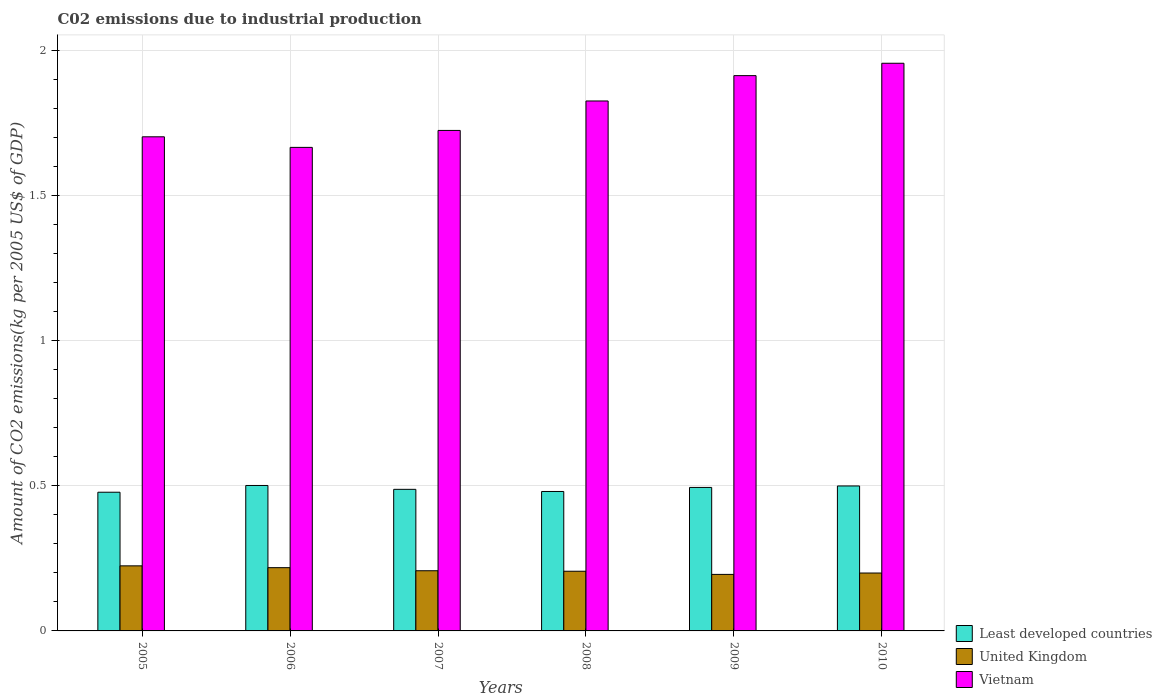How many different coloured bars are there?
Provide a succinct answer. 3. Are the number of bars per tick equal to the number of legend labels?
Your response must be concise. Yes. How many bars are there on the 3rd tick from the right?
Offer a terse response. 3. What is the label of the 5th group of bars from the left?
Ensure brevity in your answer.  2009. What is the amount of CO2 emitted due to industrial production in Least developed countries in 2006?
Provide a short and direct response. 0.5. Across all years, what is the maximum amount of CO2 emitted due to industrial production in United Kingdom?
Offer a terse response. 0.22. Across all years, what is the minimum amount of CO2 emitted due to industrial production in United Kingdom?
Offer a very short reply. 0.19. In which year was the amount of CO2 emitted due to industrial production in United Kingdom minimum?
Offer a terse response. 2009. What is the total amount of CO2 emitted due to industrial production in Least developed countries in the graph?
Give a very brief answer. 2.94. What is the difference between the amount of CO2 emitted due to industrial production in Vietnam in 2007 and that in 2008?
Keep it short and to the point. -0.1. What is the difference between the amount of CO2 emitted due to industrial production in Vietnam in 2010 and the amount of CO2 emitted due to industrial production in Least developed countries in 2005?
Offer a terse response. 1.48. What is the average amount of CO2 emitted due to industrial production in United Kingdom per year?
Provide a succinct answer. 0.21. In the year 2006, what is the difference between the amount of CO2 emitted due to industrial production in United Kingdom and amount of CO2 emitted due to industrial production in Least developed countries?
Provide a short and direct response. -0.28. What is the ratio of the amount of CO2 emitted due to industrial production in Least developed countries in 2006 to that in 2007?
Give a very brief answer. 1.03. Is the amount of CO2 emitted due to industrial production in Vietnam in 2007 less than that in 2008?
Offer a terse response. Yes. Is the difference between the amount of CO2 emitted due to industrial production in United Kingdom in 2005 and 2006 greater than the difference between the amount of CO2 emitted due to industrial production in Least developed countries in 2005 and 2006?
Provide a succinct answer. Yes. What is the difference between the highest and the second highest amount of CO2 emitted due to industrial production in United Kingdom?
Your answer should be compact. 0.01. What is the difference between the highest and the lowest amount of CO2 emitted due to industrial production in Least developed countries?
Provide a succinct answer. 0.02. Is the sum of the amount of CO2 emitted due to industrial production in Vietnam in 2009 and 2010 greater than the maximum amount of CO2 emitted due to industrial production in United Kingdom across all years?
Give a very brief answer. Yes. What does the 3rd bar from the left in 2008 represents?
Make the answer very short. Vietnam. What does the 2nd bar from the right in 2005 represents?
Keep it short and to the point. United Kingdom. How many bars are there?
Provide a short and direct response. 18. How many years are there in the graph?
Offer a terse response. 6. Does the graph contain any zero values?
Give a very brief answer. No. Does the graph contain grids?
Provide a short and direct response. Yes. Where does the legend appear in the graph?
Offer a very short reply. Bottom right. What is the title of the graph?
Provide a short and direct response. C02 emissions due to industrial production. What is the label or title of the Y-axis?
Give a very brief answer. Amount of CO2 emissions(kg per 2005 US$ of GDP). What is the Amount of CO2 emissions(kg per 2005 US$ of GDP) in Least developed countries in 2005?
Your response must be concise. 0.48. What is the Amount of CO2 emissions(kg per 2005 US$ of GDP) of United Kingdom in 2005?
Offer a very short reply. 0.22. What is the Amount of CO2 emissions(kg per 2005 US$ of GDP) of Vietnam in 2005?
Provide a succinct answer. 1.7. What is the Amount of CO2 emissions(kg per 2005 US$ of GDP) in Least developed countries in 2006?
Provide a short and direct response. 0.5. What is the Amount of CO2 emissions(kg per 2005 US$ of GDP) in United Kingdom in 2006?
Offer a very short reply. 0.22. What is the Amount of CO2 emissions(kg per 2005 US$ of GDP) in Vietnam in 2006?
Your answer should be very brief. 1.67. What is the Amount of CO2 emissions(kg per 2005 US$ of GDP) of Least developed countries in 2007?
Your answer should be very brief. 0.49. What is the Amount of CO2 emissions(kg per 2005 US$ of GDP) of United Kingdom in 2007?
Offer a terse response. 0.21. What is the Amount of CO2 emissions(kg per 2005 US$ of GDP) in Vietnam in 2007?
Offer a terse response. 1.72. What is the Amount of CO2 emissions(kg per 2005 US$ of GDP) of Least developed countries in 2008?
Ensure brevity in your answer.  0.48. What is the Amount of CO2 emissions(kg per 2005 US$ of GDP) in United Kingdom in 2008?
Make the answer very short. 0.21. What is the Amount of CO2 emissions(kg per 2005 US$ of GDP) of Vietnam in 2008?
Your answer should be compact. 1.83. What is the Amount of CO2 emissions(kg per 2005 US$ of GDP) of Least developed countries in 2009?
Your response must be concise. 0.49. What is the Amount of CO2 emissions(kg per 2005 US$ of GDP) of United Kingdom in 2009?
Offer a very short reply. 0.19. What is the Amount of CO2 emissions(kg per 2005 US$ of GDP) of Vietnam in 2009?
Provide a succinct answer. 1.91. What is the Amount of CO2 emissions(kg per 2005 US$ of GDP) in Least developed countries in 2010?
Your answer should be very brief. 0.5. What is the Amount of CO2 emissions(kg per 2005 US$ of GDP) in United Kingdom in 2010?
Make the answer very short. 0.2. What is the Amount of CO2 emissions(kg per 2005 US$ of GDP) in Vietnam in 2010?
Make the answer very short. 1.96. Across all years, what is the maximum Amount of CO2 emissions(kg per 2005 US$ of GDP) of Least developed countries?
Ensure brevity in your answer.  0.5. Across all years, what is the maximum Amount of CO2 emissions(kg per 2005 US$ of GDP) in United Kingdom?
Provide a succinct answer. 0.22. Across all years, what is the maximum Amount of CO2 emissions(kg per 2005 US$ of GDP) of Vietnam?
Offer a terse response. 1.96. Across all years, what is the minimum Amount of CO2 emissions(kg per 2005 US$ of GDP) in Least developed countries?
Provide a short and direct response. 0.48. Across all years, what is the minimum Amount of CO2 emissions(kg per 2005 US$ of GDP) in United Kingdom?
Your response must be concise. 0.19. Across all years, what is the minimum Amount of CO2 emissions(kg per 2005 US$ of GDP) in Vietnam?
Your response must be concise. 1.67. What is the total Amount of CO2 emissions(kg per 2005 US$ of GDP) of Least developed countries in the graph?
Ensure brevity in your answer.  2.94. What is the total Amount of CO2 emissions(kg per 2005 US$ of GDP) of United Kingdom in the graph?
Offer a terse response. 1.25. What is the total Amount of CO2 emissions(kg per 2005 US$ of GDP) of Vietnam in the graph?
Keep it short and to the point. 10.79. What is the difference between the Amount of CO2 emissions(kg per 2005 US$ of GDP) of Least developed countries in 2005 and that in 2006?
Keep it short and to the point. -0.02. What is the difference between the Amount of CO2 emissions(kg per 2005 US$ of GDP) in United Kingdom in 2005 and that in 2006?
Keep it short and to the point. 0.01. What is the difference between the Amount of CO2 emissions(kg per 2005 US$ of GDP) in Vietnam in 2005 and that in 2006?
Offer a terse response. 0.04. What is the difference between the Amount of CO2 emissions(kg per 2005 US$ of GDP) in Least developed countries in 2005 and that in 2007?
Keep it short and to the point. -0.01. What is the difference between the Amount of CO2 emissions(kg per 2005 US$ of GDP) of United Kingdom in 2005 and that in 2007?
Provide a succinct answer. 0.02. What is the difference between the Amount of CO2 emissions(kg per 2005 US$ of GDP) in Vietnam in 2005 and that in 2007?
Your answer should be compact. -0.02. What is the difference between the Amount of CO2 emissions(kg per 2005 US$ of GDP) of Least developed countries in 2005 and that in 2008?
Keep it short and to the point. -0. What is the difference between the Amount of CO2 emissions(kg per 2005 US$ of GDP) of United Kingdom in 2005 and that in 2008?
Make the answer very short. 0.02. What is the difference between the Amount of CO2 emissions(kg per 2005 US$ of GDP) in Vietnam in 2005 and that in 2008?
Your response must be concise. -0.12. What is the difference between the Amount of CO2 emissions(kg per 2005 US$ of GDP) in Least developed countries in 2005 and that in 2009?
Give a very brief answer. -0.02. What is the difference between the Amount of CO2 emissions(kg per 2005 US$ of GDP) of United Kingdom in 2005 and that in 2009?
Your answer should be compact. 0.03. What is the difference between the Amount of CO2 emissions(kg per 2005 US$ of GDP) of Vietnam in 2005 and that in 2009?
Your response must be concise. -0.21. What is the difference between the Amount of CO2 emissions(kg per 2005 US$ of GDP) in Least developed countries in 2005 and that in 2010?
Provide a succinct answer. -0.02. What is the difference between the Amount of CO2 emissions(kg per 2005 US$ of GDP) of United Kingdom in 2005 and that in 2010?
Give a very brief answer. 0.02. What is the difference between the Amount of CO2 emissions(kg per 2005 US$ of GDP) in Vietnam in 2005 and that in 2010?
Provide a succinct answer. -0.25. What is the difference between the Amount of CO2 emissions(kg per 2005 US$ of GDP) of Least developed countries in 2006 and that in 2007?
Keep it short and to the point. 0.01. What is the difference between the Amount of CO2 emissions(kg per 2005 US$ of GDP) in United Kingdom in 2006 and that in 2007?
Offer a very short reply. 0.01. What is the difference between the Amount of CO2 emissions(kg per 2005 US$ of GDP) in Vietnam in 2006 and that in 2007?
Your answer should be very brief. -0.06. What is the difference between the Amount of CO2 emissions(kg per 2005 US$ of GDP) of Least developed countries in 2006 and that in 2008?
Give a very brief answer. 0.02. What is the difference between the Amount of CO2 emissions(kg per 2005 US$ of GDP) in United Kingdom in 2006 and that in 2008?
Offer a terse response. 0.01. What is the difference between the Amount of CO2 emissions(kg per 2005 US$ of GDP) of Vietnam in 2006 and that in 2008?
Ensure brevity in your answer.  -0.16. What is the difference between the Amount of CO2 emissions(kg per 2005 US$ of GDP) of Least developed countries in 2006 and that in 2009?
Provide a succinct answer. 0.01. What is the difference between the Amount of CO2 emissions(kg per 2005 US$ of GDP) in United Kingdom in 2006 and that in 2009?
Your answer should be very brief. 0.02. What is the difference between the Amount of CO2 emissions(kg per 2005 US$ of GDP) of Vietnam in 2006 and that in 2009?
Your answer should be very brief. -0.25. What is the difference between the Amount of CO2 emissions(kg per 2005 US$ of GDP) in Least developed countries in 2006 and that in 2010?
Your response must be concise. 0. What is the difference between the Amount of CO2 emissions(kg per 2005 US$ of GDP) of United Kingdom in 2006 and that in 2010?
Make the answer very short. 0.02. What is the difference between the Amount of CO2 emissions(kg per 2005 US$ of GDP) in Vietnam in 2006 and that in 2010?
Keep it short and to the point. -0.29. What is the difference between the Amount of CO2 emissions(kg per 2005 US$ of GDP) in Least developed countries in 2007 and that in 2008?
Give a very brief answer. 0.01. What is the difference between the Amount of CO2 emissions(kg per 2005 US$ of GDP) of United Kingdom in 2007 and that in 2008?
Provide a succinct answer. 0. What is the difference between the Amount of CO2 emissions(kg per 2005 US$ of GDP) in Vietnam in 2007 and that in 2008?
Offer a terse response. -0.1. What is the difference between the Amount of CO2 emissions(kg per 2005 US$ of GDP) of Least developed countries in 2007 and that in 2009?
Give a very brief answer. -0.01. What is the difference between the Amount of CO2 emissions(kg per 2005 US$ of GDP) of United Kingdom in 2007 and that in 2009?
Make the answer very short. 0.01. What is the difference between the Amount of CO2 emissions(kg per 2005 US$ of GDP) of Vietnam in 2007 and that in 2009?
Your response must be concise. -0.19. What is the difference between the Amount of CO2 emissions(kg per 2005 US$ of GDP) in Least developed countries in 2007 and that in 2010?
Your answer should be very brief. -0.01. What is the difference between the Amount of CO2 emissions(kg per 2005 US$ of GDP) in United Kingdom in 2007 and that in 2010?
Make the answer very short. 0.01. What is the difference between the Amount of CO2 emissions(kg per 2005 US$ of GDP) in Vietnam in 2007 and that in 2010?
Offer a very short reply. -0.23. What is the difference between the Amount of CO2 emissions(kg per 2005 US$ of GDP) in Least developed countries in 2008 and that in 2009?
Your response must be concise. -0.01. What is the difference between the Amount of CO2 emissions(kg per 2005 US$ of GDP) in United Kingdom in 2008 and that in 2009?
Give a very brief answer. 0.01. What is the difference between the Amount of CO2 emissions(kg per 2005 US$ of GDP) in Vietnam in 2008 and that in 2009?
Your answer should be compact. -0.09. What is the difference between the Amount of CO2 emissions(kg per 2005 US$ of GDP) in Least developed countries in 2008 and that in 2010?
Provide a succinct answer. -0.02. What is the difference between the Amount of CO2 emissions(kg per 2005 US$ of GDP) in United Kingdom in 2008 and that in 2010?
Make the answer very short. 0.01. What is the difference between the Amount of CO2 emissions(kg per 2005 US$ of GDP) of Vietnam in 2008 and that in 2010?
Offer a very short reply. -0.13. What is the difference between the Amount of CO2 emissions(kg per 2005 US$ of GDP) of Least developed countries in 2009 and that in 2010?
Provide a succinct answer. -0.01. What is the difference between the Amount of CO2 emissions(kg per 2005 US$ of GDP) in United Kingdom in 2009 and that in 2010?
Offer a terse response. -0. What is the difference between the Amount of CO2 emissions(kg per 2005 US$ of GDP) of Vietnam in 2009 and that in 2010?
Provide a succinct answer. -0.04. What is the difference between the Amount of CO2 emissions(kg per 2005 US$ of GDP) in Least developed countries in 2005 and the Amount of CO2 emissions(kg per 2005 US$ of GDP) in United Kingdom in 2006?
Provide a short and direct response. 0.26. What is the difference between the Amount of CO2 emissions(kg per 2005 US$ of GDP) in Least developed countries in 2005 and the Amount of CO2 emissions(kg per 2005 US$ of GDP) in Vietnam in 2006?
Provide a succinct answer. -1.19. What is the difference between the Amount of CO2 emissions(kg per 2005 US$ of GDP) in United Kingdom in 2005 and the Amount of CO2 emissions(kg per 2005 US$ of GDP) in Vietnam in 2006?
Ensure brevity in your answer.  -1.44. What is the difference between the Amount of CO2 emissions(kg per 2005 US$ of GDP) of Least developed countries in 2005 and the Amount of CO2 emissions(kg per 2005 US$ of GDP) of United Kingdom in 2007?
Keep it short and to the point. 0.27. What is the difference between the Amount of CO2 emissions(kg per 2005 US$ of GDP) of Least developed countries in 2005 and the Amount of CO2 emissions(kg per 2005 US$ of GDP) of Vietnam in 2007?
Provide a short and direct response. -1.25. What is the difference between the Amount of CO2 emissions(kg per 2005 US$ of GDP) in United Kingdom in 2005 and the Amount of CO2 emissions(kg per 2005 US$ of GDP) in Vietnam in 2007?
Ensure brevity in your answer.  -1.5. What is the difference between the Amount of CO2 emissions(kg per 2005 US$ of GDP) of Least developed countries in 2005 and the Amount of CO2 emissions(kg per 2005 US$ of GDP) of United Kingdom in 2008?
Provide a succinct answer. 0.27. What is the difference between the Amount of CO2 emissions(kg per 2005 US$ of GDP) of Least developed countries in 2005 and the Amount of CO2 emissions(kg per 2005 US$ of GDP) of Vietnam in 2008?
Provide a short and direct response. -1.35. What is the difference between the Amount of CO2 emissions(kg per 2005 US$ of GDP) of United Kingdom in 2005 and the Amount of CO2 emissions(kg per 2005 US$ of GDP) of Vietnam in 2008?
Provide a short and direct response. -1.6. What is the difference between the Amount of CO2 emissions(kg per 2005 US$ of GDP) of Least developed countries in 2005 and the Amount of CO2 emissions(kg per 2005 US$ of GDP) of United Kingdom in 2009?
Your answer should be compact. 0.28. What is the difference between the Amount of CO2 emissions(kg per 2005 US$ of GDP) in Least developed countries in 2005 and the Amount of CO2 emissions(kg per 2005 US$ of GDP) in Vietnam in 2009?
Ensure brevity in your answer.  -1.44. What is the difference between the Amount of CO2 emissions(kg per 2005 US$ of GDP) in United Kingdom in 2005 and the Amount of CO2 emissions(kg per 2005 US$ of GDP) in Vietnam in 2009?
Provide a short and direct response. -1.69. What is the difference between the Amount of CO2 emissions(kg per 2005 US$ of GDP) of Least developed countries in 2005 and the Amount of CO2 emissions(kg per 2005 US$ of GDP) of United Kingdom in 2010?
Offer a very short reply. 0.28. What is the difference between the Amount of CO2 emissions(kg per 2005 US$ of GDP) in Least developed countries in 2005 and the Amount of CO2 emissions(kg per 2005 US$ of GDP) in Vietnam in 2010?
Offer a terse response. -1.48. What is the difference between the Amount of CO2 emissions(kg per 2005 US$ of GDP) of United Kingdom in 2005 and the Amount of CO2 emissions(kg per 2005 US$ of GDP) of Vietnam in 2010?
Provide a succinct answer. -1.73. What is the difference between the Amount of CO2 emissions(kg per 2005 US$ of GDP) of Least developed countries in 2006 and the Amount of CO2 emissions(kg per 2005 US$ of GDP) of United Kingdom in 2007?
Offer a terse response. 0.29. What is the difference between the Amount of CO2 emissions(kg per 2005 US$ of GDP) in Least developed countries in 2006 and the Amount of CO2 emissions(kg per 2005 US$ of GDP) in Vietnam in 2007?
Give a very brief answer. -1.22. What is the difference between the Amount of CO2 emissions(kg per 2005 US$ of GDP) of United Kingdom in 2006 and the Amount of CO2 emissions(kg per 2005 US$ of GDP) of Vietnam in 2007?
Your answer should be compact. -1.51. What is the difference between the Amount of CO2 emissions(kg per 2005 US$ of GDP) of Least developed countries in 2006 and the Amount of CO2 emissions(kg per 2005 US$ of GDP) of United Kingdom in 2008?
Offer a terse response. 0.3. What is the difference between the Amount of CO2 emissions(kg per 2005 US$ of GDP) of Least developed countries in 2006 and the Amount of CO2 emissions(kg per 2005 US$ of GDP) of Vietnam in 2008?
Make the answer very short. -1.33. What is the difference between the Amount of CO2 emissions(kg per 2005 US$ of GDP) of United Kingdom in 2006 and the Amount of CO2 emissions(kg per 2005 US$ of GDP) of Vietnam in 2008?
Provide a short and direct response. -1.61. What is the difference between the Amount of CO2 emissions(kg per 2005 US$ of GDP) of Least developed countries in 2006 and the Amount of CO2 emissions(kg per 2005 US$ of GDP) of United Kingdom in 2009?
Ensure brevity in your answer.  0.31. What is the difference between the Amount of CO2 emissions(kg per 2005 US$ of GDP) in Least developed countries in 2006 and the Amount of CO2 emissions(kg per 2005 US$ of GDP) in Vietnam in 2009?
Ensure brevity in your answer.  -1.41. What is the difference between the Amount of CO2 emissions(kg per 2005 US$ of GDP) in United Kingdom in 2006 and the Amount of CO2 emissions(kg per 2005 US$ of GDP) in Vietnam in 2009?
Keep it short and to the point. -1.7. What is the difference between the Amount of CO2 emissions(kg per 2005 US$ of GDP) in Least developed countries in 2006 and the Amount of CO2 emissions(kg per 2005 US$ of GDP) in United Kingdom in 2010?
Provide a succinct answer. 0.3. What is the difference between the Amount of CO2 emissions(kg per 2005 US$ of GDP) in Least developed countries in 2006 and the Amount of CO2 emissions(kg per 2005 US$ of GDP) in Vietnam in 2010?
Your response must be concise. -1.46. What is the difference between the Amount of CO2 emissions(kg per 2005 US$ of GDP) in United Kingdom in 2006 and the Amount of CO2 emissions(kg per 2005 US$ of GDP) in Vietnam in 2010?
Keep it short and to the point. -1.74. What is the difference between the Amount of CO2 emissions(kg per 2005 US$ of GDP) of Least developed countries in 2007 and the Amount of CO2 emissions(kg per 2005 US$ of GDP) of United Kingdom in 2008?
Keep it short and to the point. 0.28. What is the difference between the Amount of CO2 emissions(kg per 2005 US$ of GDP) in Least developed countries in 2007 and the Amount of CO2 emissions(kg per 2005 US$ of GDP) in Vietnam in 2008?
Your answer should be very brief. -1.34. What is the difference between the Amount of CO2 emissions(kg per 2005 US$ of GDP) of United Kingdom in 2007 and the Amount of CO2 emissions(kg per 2005 US$ of GDP) of Vietnam in 2008?
Your response must be concise. -1.62. What is the difference between the Amount of CO2 emissions(kg per 2005 US$ of GDP) in Least developed countries in 2007 and the Amount of CO2 emissions(kg per 2005 US$ of GDP) in United Kingdom in 2009?
Your answer should be very brief. 0.29. What is the difference between the Amount of CO2 emissions(kg per 2005 US$ of GDP) in Least developed countries in 2007 and the Amount of CO2 emissions(kg per 2005 US$ of GDP) in Vietnam in 2009?
Ensure brevity in your answer.  -1.43. What is the difference between the Amount of CO2 emissions(kg per 2005 US$ of GDP) in United Kingdom in 2007 and the Amount of CO2 emissions(kg per 2005 US$ of GDP) in Vietnam in 2009?
Your response must be concise. -1.71. What is the difference between the Amount of CO2 emissions(kg per 2005 US$ of GDP) of Least developed countries in 2007 and the Amount of CO2 emissions(kg per 2005 US$ of GDP) of United Kingdom in 2010?
Your answer should be very brief. 0.29. What is the difference between the Amount of CO2 emissions(kg per 2005 US$ of GDP) in Least developed countries in 2007 and the Amount of CO2 emissions(kg per 2005 US$ of GDP) in Vietnam in 2010?
Provide a succinct answer. -1.47. What is the difference between the Amount of CO2 emissions(kg per 2005 US$ of GDP) of United Kingdom in 2007 and the Amount of CO2 emissions(kg per 2005 US$ of GDP) of Vietnam in 2010?
Your response must be concise. -1.75. What is the difference between the Amount of CO2 emissions(kg per 2005 US$ of GDP) of Least developed countries in 2008 and the Amount of CO2 emissions(kg per 2005 US$ of GDP) of United Kingdom in 2009?
Your answer should be very brief. 0.29. What is the difference between the Amount of CO2 emissions(kg per 2005 US$ of GDP) of Least developed countries in 2008 and the Amount of CO2 emissions(kg per 2005 US$ of GDP) of Vietnam in 2009?
Offer a very short reply. -1.43. What is the difference between the Amount of CO2 emissions(kg per 2005 US$ of GDP) in United Kingdom in 2008 and the Amount of CO2 emissions(kg per 2005 US$ of GDP) in Vietnam in 2009?
Offer a very short reply. -1.71. What is the difference between the Amount of CO2 emissions(kg per 2005 US$ of GDP) of Least developed countries in 2008 and the Amount of CO2 emissions(kg per 2005 US$ of GDP) of United Kingdom in 2010?
Offer a terse response. 0.28. What is the difference between the Amount of CO2 emissions(kg per 2005 US$ of GDP) of Least developed countries in 2008 and the Amount of CO2 emissions(kg per 2005 US$ of GDP) of Vietnam in 2010?
Your answer should be very brief. -1.48. What is the difference between the Amount of CO2 emissions(kg per 2005 US$ of GDP) in United Kingdom in 2008 and the Amount of CO2 emissions(kg per 2005 US$ of GDP) in Vietnam in 2010?
Offer a terse response. -1.75. What is the difference between the Amount of CO2 emissions(kg per 2005 US$ of GDP) in Least developed countries in 2009 and the Amount of CO2 emissions(kg per 2005 US$ of GDP) in United Kingdom in 2010?
Give a very brief answer. 0.29. What is the difference between the Amount of CO2 emissions(kg per 2005 US$ of GDP) of Least developed countries in 2009 and the Amount of CO2 emissions(kg per 2005 US$ of GDP) of Vietnam in 2010?
Your response must be concise. -1.46. What is the difference between the Amount of CO2 emissions(kg per 2005 US$ of GDP) of United Kingdom in 2009 and the Amount of CO2 emissions(kg per 2005 US$ of GDP) of Vietnam in 2010?
Your response must be concise. -1.76. What is the average Amount of CO2 emissions(kg per 2005 US$ of GDP) of Least developed countries per year?
Your answer should be compact. 0.49. What is the average Amount of CO2 emissions(kg per 2005 US$ of GDP) in United Kingdom per year?
Provide a short and direct response. 0.21. What is the average Amount of CO2 emissions(kg per 2005 US$ of GDP) of Vietnam per year?
Your answer should be compact. 1.8. In the year 2005, what is the difference between the Amount of CO2 emissions(kg per 2005 US$ of GDP) of Least developed countries and Amount of CO2 emissions(kg per 2005 US$ of GDP) of United Kingdom?
Provide a succinct answer. 0.25. In the year 2005, what is the difference between the Amount of CO2 emissions(kg per 2005 US$ of GDP) in Least developed countries and Amount of CO2 emissions(kg per 2005 US$ of GDP) in Vietnam?
Provide a short and direct response. -1.22. In the year 2005, what is the difference between the Amount of CO2 emissions(kg per 2005 US$ of GDP) of United Kingdom and Amount of CO2 emissions(kg per 2005 US$ of GDP) of Vietnam?
Offer a very short reply. -1.48. In the year 2006, what is the difference between the Amount of CO2 emissions(kg per 2005 US$ of GDP) in Least developed countries and Amount of CO2 emissions(kg per 2005 US$ of GDP) in United Kingdom?
Make the answer very short. 0.28. In the year 2006, what is the difference between the Amount of CO2 emissions(kg per 2005 US$ of GDP) of Least developed countries and Amount of CO2 emissions(kg per 2005 US$ of GDP) of Vietnam?
Keep it short and to the point. -1.17. In the year 2006, what is the difference between the Amount of CO2 emissions(kg per 2005 US$ of GDP) in United Kingdom and Amount of CO2 emissions(kg per 2005 US$ of GDP) in Vietnam?
Offer a terse response. -1.45. In the year 2007, what is the difference between the Amount of CO2 emissions(kg per 2005 US$ of GDP) in Least developed countries and Amount of CO2 emissions(kg per 2005 US$ of GDP) in United Kingdom?
Offer a terse response. 0.28. In the year 2007, what is the difference between the Amount of CO2 emissions(kg per 2005 US$ of GDP) of Least developed countries and Amount of CO2 emissions(kg per 2005 US$ of GDP) of Vietnam?
Provide a short and direct response. -1.24. In the year 2007, what is the difference between the Amount of CO2 emissions(kg per 2005 US$ of GDP) in United Kingdom and Amount of CO2 emissions(kg per 2005 US$ of GDP) in Vietnam?
Offer a very short reply. -1.52. In the year 2008, what is the difference between the Amount of CO2 emissions(kg per 2005 US$ of GDP) in Least developed countries and Amount of CO2 emissions(kg per 2005 US$ of GDP) in United Kingdom?
Provide a succinct answer. 0.27. In the year 2008, what is the difference between the Amount of CO2 emissions(kg per 2005 US$ of GDP) in Least developed countries and Amount of CO2 emissions(kg per 2005 US$ of GDP) in Vietnam?
Offer a very short reply. -1.35. In the year 2008, what is the difference between the Amount of CO2 emissions(kg per 2005 US$ of GDP) in United Kingdom and Amount of CO2 emissions(kg per 2005 US$ of GDP) in Vietnam?
Make the answer very short. -1.62. In the year 2009, what is the difference between the Amount of CO2 emissions(kg per 2005 US$ of GDP) of Least developed countries and Amount of CO2 emissions(kg per 2005 US$ of GDP) of United Kingdom?
Keep it short and to the point. 0.3. In the year 2009, what is the difference between the Amount of CO2 emissions(kg per 2005 US$ of GDP) of Least developed countries and Amount of CO2 emissions(kg per 2005 US$ of GDP) of Vietnam?
Offer a terse response. -1.42. In the year 2009, what is the difference between the Amount of CO2 emissions(kg per 2005 US$ of GDP) in United Kingdom and Amount of CO2 emissions(kg per 2005 US$ of GDP) in Vietnam?
Give a very brief answer. -1.72. In the year 2010, what is the difference between the Amount of CO2 emissions(kg per 2005 US$ of GDP) of Least developed countries and Amount of CO2 emissions(kg per 2005 US$ of GDP) of United Kingdom?
Provide a short and direct response. 0.3. In the year 2010, what is the difference between the Amount of CO2 emissions(kg per 2005 US$ of GDP) in Least developed countries and Amount of CO2 emissions(kg per 2005 US$ of GDP) in Vietnam?
Provide a short and direct response. -1.46. In the year 2010, what is the difference between the Amount of CO2 emissions(kg per 2005 US$ of GDP) in United Kingdom and Amount of CO2 emissions(kg per 2005 US$ of GDP) in Vietnam?
Your response must be concise. -1.76. What is the ratio of the Amount of CO2 emissions(kg per 2005 US$ of GDP) in Least developed countries in 2005 to that in 2006?
Ensure brevity in your answer.  0.95. What is the ratio of the Amount of CO2 emissions(kg per 2005 US$ of GDP) of United Kingdom in 2005 to that in 2006?
Give a very brief answer. 1.03. What is the ratio of the Amount of CO2 emissions(kg per 2005 US$ of GDP) of Vietnam in 2005 to that in 2006?
Provide a short and direct response. 1.02. What is the ratio of the Amount of CO2 emissions(kg per 2005 US$ of GDP) of Least developed countries in 2005 to that in 2007?
Your answer should be very brief. 0.98. What is the ratio of the Amount of CO2 emissions(kg per 2005 US$ of GDP) in United Kingdom in 2005 to that in 2007?
Offer a terse response. 1.08. What is the ratio of the Amount of CO2 emissions(kg per 2005 US$ of GDP) in Vietnam in 2005 to that in 2007?
Keep it short and to the point. 0.99. What is the ratio of the Amount of CO2 emissions(kg per 2005 US$ of GDP) in Least developed countries in 2005 to that in 2008?
Your answer should be compact. 0.99. What is the ratio of the Amount of CO2 emissions(kg per 2005 US$ of GDP) of United Kingdom in 2005 to that in 2008?
Make the answer very short. 1.09. What is the ratio of the Amount of CO2 emissions(kg per 2005 US$ of GDP) of Vietnam in 2005 to that in 2008?
Give a very brief answer. 0.93. What is the ratio of the Amount of CO2 emissions(kg per 2005 US$ of GDP) in Least developed countries in 2005 to that in 2009?
Provide a short and direct response. 0.97. What is the ratio of the Amount of CO2 emissions(kg per 2005 US$ of GDP) of United Kingdom in 2005 to that in 2009?
Your answer should be compact. 1.15. What is the ratio of the Amount of CO2 emissions(kg per 2005 US$ of GDP) of Vietnam in 2005 to that in 2009?
Keep it short and to the point. 0.89. What is the ratio of the Amount of CO2 emissions(kg per 2005 US$ of GDP) in Least developed countries in 2005 to that in 2010?
Ensure brevity in your answer.  0.96. What is the ratio of the Amount of CO2 emissions(kg per 2005 US$ of GDP) of United Kingdom in 2005 to that in 2010?
Your answer should be very brief. 1.12. What is the ratio of the Amount of CO2 emissions(kg per 2005 US$ of GDP) of Vietnam in 2005 to that in 2010?
Offer a very short reply. 0.87. What is the ratio of the Amount of CO2 emissions(kg per 2005 US$ of GDP) of Least developed countries in 2006 to that in 2007?
Provide a short and direct response. 1.03. What is the ratio of the Amount of CO2 emissions(kg per 2005 US$ of GDP) in United Kingdom in 2006 to that in 2007?
Provide a succinct answer. 1.05. What is the ratio of the Amount of CO2 emissions(kg per 2005 US$ of GDP) in Vietnam in 2006 to that in 2007?
Offer a very short reply. 0.97. What is the ratio of the Amount of CO2 emissions(kg per 2005 US$ of GDP) of Least developed countries in 2006 to that in 2008?
Provide a short and direct response. 1.04. What is the ratio of the Amount of CO2 emissions(kg per 2005 US$ of GDP) in United Kingdom in 2006 to that in 2008?
Ensure brevity in your answer.  1.06. What is the ratio of the Amount of CO2 emissions(kg per 2005 US$ of GDP) in Vietnam in 2006 to that in 2008?
Keep it short and to the point. 0.91. What is the ratio of the Amount of CO2 emissions(kg per 2005 US$ of GDP) in Least developed countries in 2006 to that in 2009?
Your answer should be compact. 1.01. What is the ratio of the Amount of CO2 emissions(kg per 2005 US$ of GDP) in United Kingdom in 2006 to that in 2009?
Provide a short and direct response. 1.12. What is the ratio of the Amount of CO2 emissions(kg per 2005 US$ of GDP) of Vietnam in 2006 to that in 2009?
Your answer should be very brief. 0.87. What is the ratio of the Amount of CO2 emissions(kg per 2005 US$ of GDP) in Least developed countries in 2006 to that in 2010?
Offer a very short reply. 1. What is the ratio of the Amount of CO2 emissions(kg per 2005 US$ of GDP) in United Kingdom in 2006 to that in 2010?
Make the answer very short. 1.09. What is the ratio of the Amount of CO2 emissions(kg per 2005 US$ of GDP) of Vietnam in 2006 to that in 2010?
Ensure brevity in your answer.  0.85. What is the ratio of the Amount of CO2 emissions(kg per 2005 US$ of GDP) of Least developed countries in 2007 to that in 2008?
Make the answer very short. 1.02. What is the ratio of the Amount of CO2 emissions(kg per 2005 US$ of GDP) in United Kingdom in 2007 to that in 2008?
Keep it short and to the point. 1.01. What is the ratio of the Amount of CO2 emissions(kg per 2005 US$ of GDP) in Vietnam in 2007 to that in 2008?
Provide a succinct answer. 0.94. What is the ratio of the Amount of CO2 emissions(kg per 2005 US$ of GDP) in Least developed countries in 2007 to that in 2009?
Keep it short and to the point. 0.99. What is the ratio of the Amount of CO2 emissions(kg per 2005 US$ of GDP) in United Kingdom in 2007 to that in 2009?
Offer a very short reply. 1.06. What is the ratio of the Amount of CO2 emissions(kg per 2005 US$ of GDP) of Vietnam in 2007 to that in 2009?
Your answer should be very brief. 0.9. What is the ratio of the Amount of CO2 emissions(kg per 2005 US$ of GDP) of Least developed countries in 2007 to that in 2010?
Ensure brevity in your answer.  0.98. What is the ratio of the Amount of CO2 emissions(kg per 2005 US$ of GDP) of United Kingdom in 2007 to that in 2010?
Your answer should be compact. 1.04. What is the ratio of the Amount of CO2 emissions(kg per 2005 US$ of GDP) of Vietnam in 2007 to that in 2010?
Keep it short and to the point. 0.88. What is the ratio of the Amount of CO2 emissions(kg per 2005 US$ of GDP) of Least developed countries in 2008 to that in 2009?
Offer a very short reply. 0.97. What is the ratio of the Amount of CO2 emissions(kg per 2005 US$ of GDP) of United Kingdom in 2008 to that in 2009?
Your answer should be compact. 1.06. What is the ratio of the Amount of CO2 emissions(kg per 2005 US$ of GDP) in Vietnam in 2008 to that in 2009?
Make the answer very short. 0.95. What is the ratio of the Amount of CO2 emissions(kg per 2005 US$ of GDP) of Least developed countries in 2008 to that in 2010?
Offer a very short reply. 0.96. What is the ratio of the Amount of CO2 emissions(kg per 2005 US$ of GDP) of United Kingdom in 2008 to that in 2010?
Offer a very short reply. 1.03. What is the ratio of the Amount of CO2 emissions(kg per 2005 US$ of GDP) of Vietnam in 2008 to that in 2010?
Give a very brief answer. 0.93. What is the ratio of the Amount of CO2 emissions(kg per 2005 US$ of GDP) in United Kingdom in 2009 to that in 2010?
Provide a succinct answer. 0.98. What is the ratio of the Amount of CO2 emissions(kg per 2005 US$ of GDP) in Vietnam in 2009 to that in 2010?
Keep it short and to the point. 0.98. What is the difference between the highest and the second highest Amount of CO2 emissions(kg per 2005 US$ of GDP) in Least developed countries?
Your answer should be very brief. 0. What is the difference between the highest and the second highest Amount of CO2 emissions(kg per 2005 US$ of GDP) in United Kingdom?
Offer a very short reply. 0.01. What is the difference between the highest and the second highest Amount of CO2 emissions(kg per 2005 US$ of GDP) in Vietnam?
Provide a short and direct response. 0.04. What is the difference between the highest and the lowest Amount of CO2 emissions(kg per 2005 US$ of GDP) of Least developed countries?
Your response must be concise. 0.02. What is the difference between the highest and the lowest Amount of CO2 emissions(kg per 2005 US$ of GDP) in United Kingdom?
Keep it short and to the point. 0.03. What is the difference between the highest and the lowest Amount of CO2 emissions(kg per 2005 US$ of GDP) in Vietnam?
Keep it short and to the point. 0.29. 